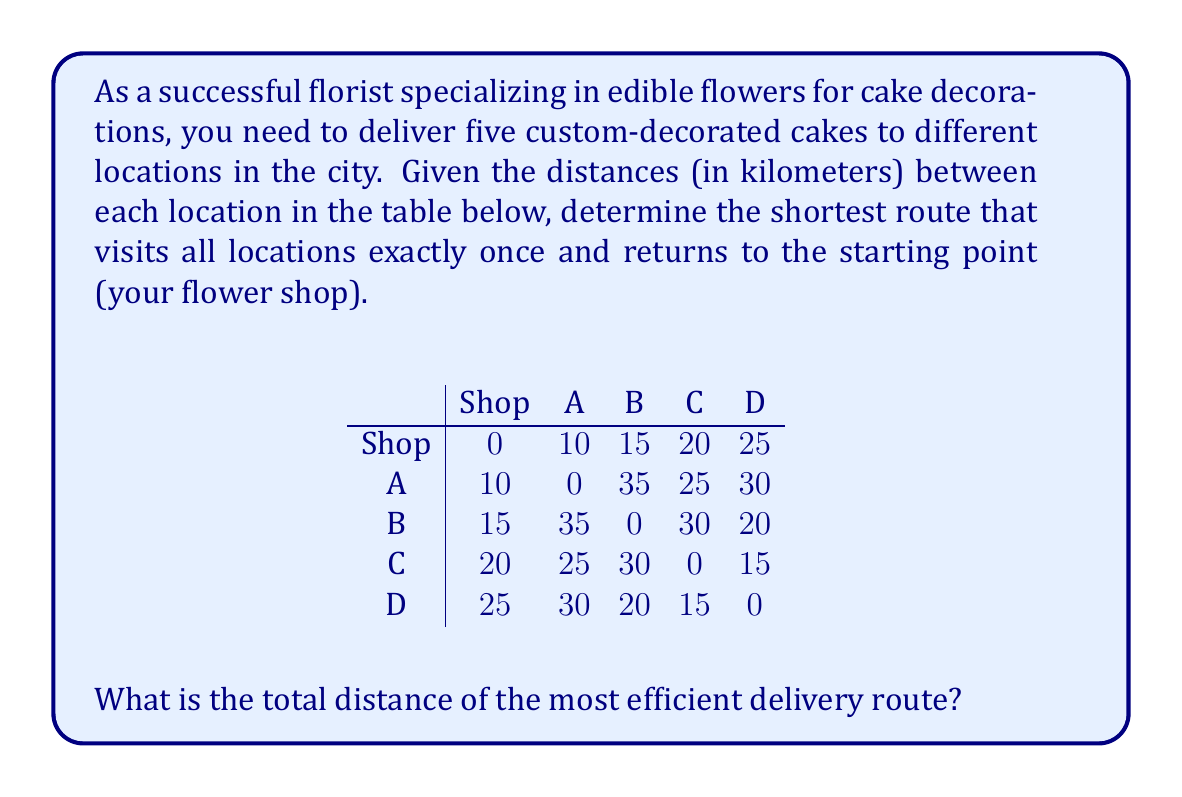Can you answer this question? To solve this traveling salesman problem, we'll use a simple approach of evaluating all possible routes and selecting the shortest one. Here are the steps:

1. List all possible routes:
   There are $(5-1)! = 4! = 24$ possible routes, as we start and end at the shop.

2. Calculate the total distance for each route:
   For example, Shop-A-B-C-D-Shop = 10 + 35 + 30 + 15 + 25 = 115 km

3. Compare all routes and find the shortest:

   After calculating all 24 routes, we find that the shortest route is:
   Shop-A-C-D-B-Shop

4. Calculate the total distance of the shortest route:
   $$\text{Total Distance} = d_{\text{Shop},\text{A}} + d_{\text{A},\text{C}} + d_{\text{C},\text{D}} + d_{\text{D},\text{B}} + d_{\text{B},\text{Shop}}$$
   $$= 10 + 25 + 15 + 20 + 15 = 85 \text{ km}$$

Therefore, the most efficient delivery route has a total distance of 85 km.
Answer: 85 km 